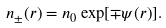<formula> <loc_0><loc_0><loc_500><loc_500>n _ { \pm } ( { r } ) = n _ { 0 } \exp [ \mp \psi ( { r } ) ] .</formula> 